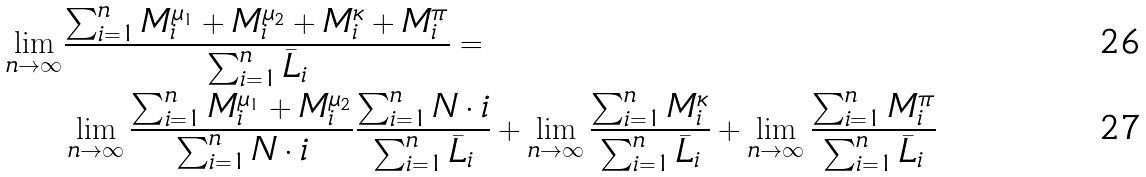Convert formula to latex. <formula><loc_0><loc_0><loc_500><loc_500>\lim _ { n \rightarrow \infty } & \frac { \sum _ { i = 1 } ^ { n } M ^ { \mu _ { 1 } } _ { i } + M ^ { \mu _ { 2 } } _ { i } + M ^ { \kappa } _ { i } + M ^ { \pi } _ { i } } { \sum _ { i = 1 } ^ { n } \bar { L } _ { i } } = \\ & \lim _ { n \rightarrow \infty } \frac { \sum _ { i = 1 } ^ { n } M ^ { \mu _ { 1 } } _ { i } + M ^ { \mu _ { 2 } } _ { i } } { \sum _ { i = 1 } ^ { n } N \cdot i } \frac { \sum _ { i = 1 } ^ { n } N \cdot i } { \sum _ { i = 1 } ^ { n } \bar { L } _ { i } } + \lim _ { n \rightarrow \infty } \frac { \sum _ { i = 1 } ^ { n } M ^ { \kappa } _ { i } } { \sum _ { i = 1 } ^ { n } \bar { L } _ { i } } + \lim _ { n \rightarrow \infty } \frac { \sum _ { i = 1 } ^ { n } M ^ { \pi } _ { i } } { \sum _ { i = 1 } ^ { n } \bar { L } _ { i } }</formula> 